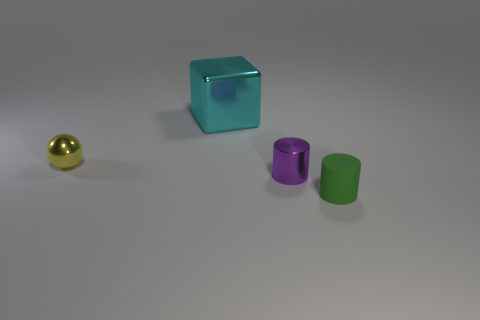There is a thing that is on the left side of the green object and in front of the small yellow ball; what is its size?
Your answer should be compact. Small. What number of small purple cylinders are in front of the yellow metal ball?
Your answer should be compact. 1. The metal thing that is both in front of the big cyan object and left of the tiny purple object has what shape?
Your answer should be compact. Sphere. How many cylinders are small purple metallic things or cyan objects?
Provide a short and direct response. 1. Are there fewer matte cylinders behind the small green cylinder than big gray shiny cubes?
Your answer should be very brief. No. What is the color of the metal thing that is both on the right side of the tiny yellow metallic ball and on the left side of the metal cylinder?
Make the answer very short. Cyan. How many other objects are there of the same shape as the small green rubber object?
Give a very brief answer. 1. Are there fewer tiny purple metallic cylinders that are on the right side of the tiny green object than objects that are in front of the small purple shiny thing?
Provide a succinct answer. Yes. Are the green cylinder and the small object that is on the left side of the big object made of the same material?
Give a very brief answer. No. Is there any other thing that is made of the same material as the green thing?
Give a very brief answer. No. 